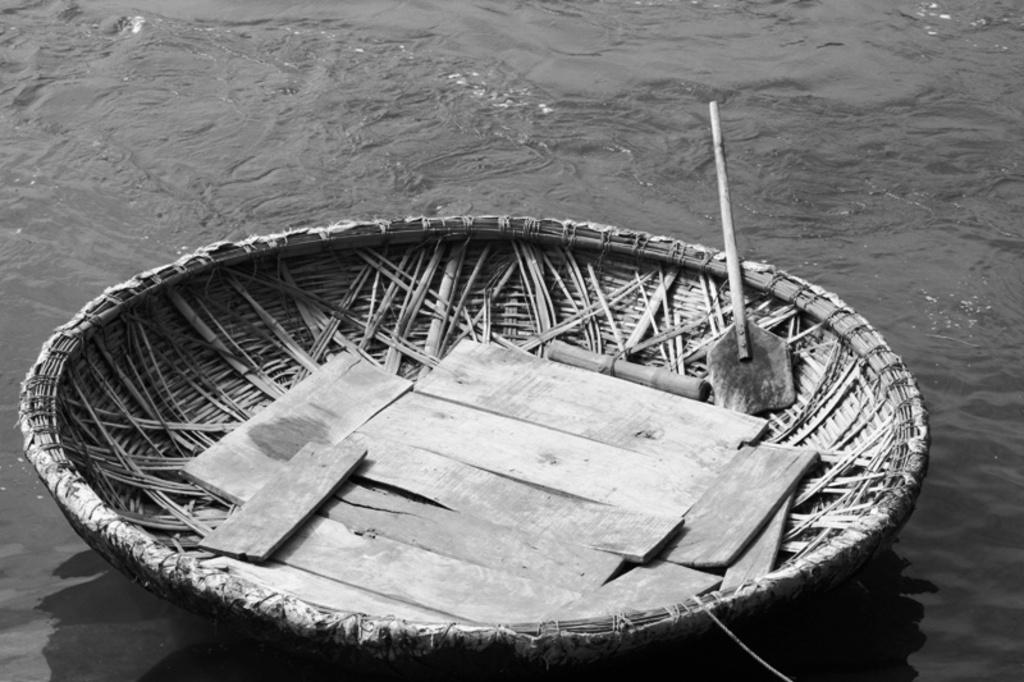What is the main subject of the image? The main subject of the image is a boat. Where is the boat located? The boat is on the surface of water. Are there any dinosaurs swimming in the water near the boat? No, there are no dinosaurs present in the image. 